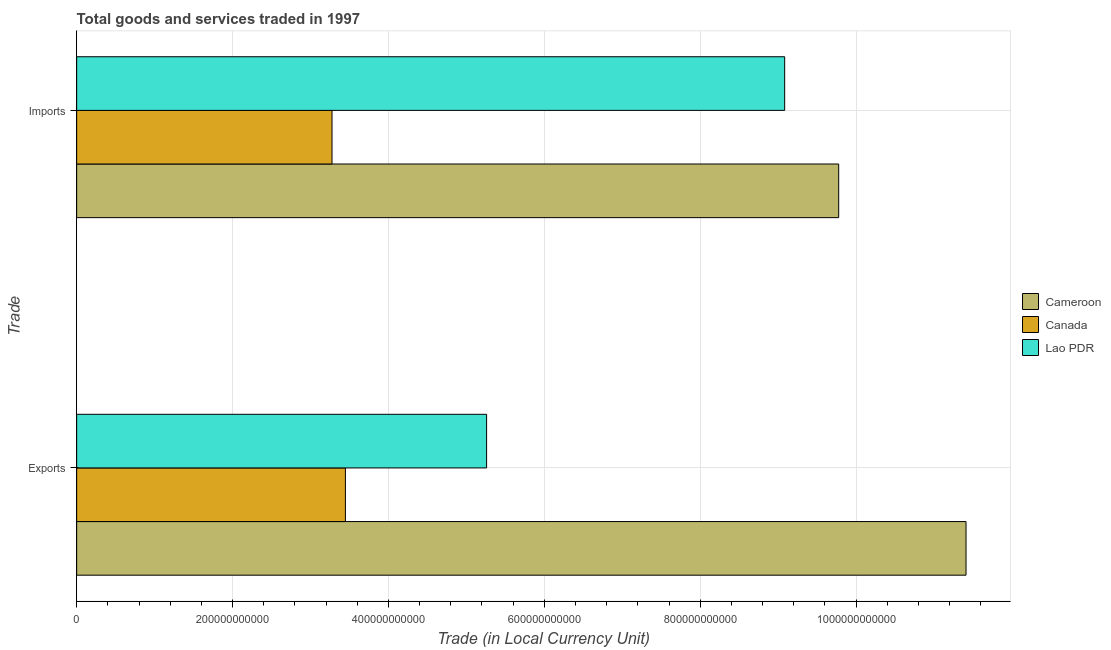How many groups of bars are there?
Make the answer very short. 2. Are the number of bars per tick equal to the number of legend labels?
Your response must be concise. Yes. How many bars are there on the 2nd tick from the top?
Offer a very short reply. 3. How many bars are there on the 2nd tick from the bottom?
Give a very brief answer. 3. What is the label of the 1st group of bars from the top?
Your answer should be very brief. Imports. What is the imports of goods and services in Canada?
Provide a succinct answer. 3.28e+11. Across all countries, what is the maximum imports of goods and services?
Give a very brief answer. 9.78e+11. Across all countries, what is the minimum imports of goods and services?
Your response must be concise. 3.28e+11. In which country was the imports of goods and services maximum?
Keep it short and to the point. Cameroon. In which country was the export of goods and services minimum?
Give a very brief answer. Canada. What is the total imports of goods and services in the graph?
Offer a terse response. 2.21e+12. What is the difference between the export of goods and services in Canada and that in Cameroon?
Ensure brevity in your answer.  -7.96e+11. What is the difference between the imports of goods and services in Canada and the export of goods and services in Cameroon?
Offer a very short reply. -8.13e+11. What is the average export of goods and services per country?
Your answer should be compact. 6.71e+11. What is the difference between the imports of goods and services and export of goods and services in Cameroon?
Offer a terse response. -1.63e+11. What is the ratio of the export of goods and services in Lao PDR to that in Cameroon?
Offer a very short reply. 0.46. In how many countries, is the imports of goods and services greater than the average imports of goods and services taken over all countries?
Keep it short and to the point. 2. What does the 2nd bar from the bottom in Exports represents?
Make the answer very short. Canada. How many bars are there?
Your answer should be very brief. 6. How many countries are there in the graph?
Provide a short and direct response. 3. What is the difference between two consecutive major ticks on the X-axis?
Keep it short and to the point. 2.00e+11. Does the graph contain any zero values?
Your answer should be very brief. No. Does the graph contain grids?
Keep it short and to the point. Yes. How many legend labels are there?
Provide a succinct answer. 3. How are the legend labels stacked?
Ensure brevity in your answer.  Vertical. What is the title of the graph?
Your response must be concise. Total goods and services traded in 1997. What is the label or title of the X-axis?
Ensure brevity in your answer.  Trade (in Local Currency Unit). What is the label or title of the Y-axis?
Provide a short and direct response. Trade. What is the Trade (in Local Currency Unit) in Cameroon in Exports?
Ensure brevity in your answer.  1.14e+12. What is the Trade (in Local Currency Unit) of Canada in Exports?
Provide a short and direct response. 3.45e+11. What is the Trade (in Local Currency Unit) of Lao PDR in Exports?
Make the answer very short. 5.26e+11. What is the Trade (in Local Currency Unit) of Cameroon in Imports?
Provide a short and direct response. 9.78e+11. What is the Trade (in Local Currency Unit) in Canada in Imports?
Your answer should be compact. 3.28e+11. What is the Trade (in Local Currency Unit) of Lao PDR in Imports?
Offer a very short reply. 9.08e+11. Across all Trade, what is the maximum Trade (in Local Currency Unit) of Cameroon?
Provide a short and direct response. 1.14e+12. Across all Trade, what is the maximum Trade (in Local Currency Unit) in Canada?
Provide a succinct answer. 3.45e+11. Across all Trade, what is the maximum Trade (in Local Currency Unit) of Lao PDR?
Make the answer very short. 9.08e+11. Across all Trade, what is the minimum Trade (in Local Currency Unit) in Cameroon?
Offer a terse response. 9.78e+11. Across all Trade, what is the minimum Trade (in Local Currency Unit) of Canada?
Offer a terse response. 3.28e+11. Across all Trade, what is the minimum Trade (in Local Currency Unit) in Lao PDR?
Provide a succinct answer. 5.26e+11. What is the total Trade (in Local Currency Unit) in Cameroon in the graph?
Offer a very short reply. 2.12e+12. What is the total Trade (in Local Currency Unit) in Canada in the graph?
Provide a short and direct response. 6.72e+11. What is the total Trade (in Local Currency Unit) in Lao PDR in the graph?
Your answer should be compact. 1.43e+12. What is the difference between the Trade (in Local Currency Unit) of Cameroon in Exports and that in Imports?
Give a very brief answer. 1.63e+11. What is the difference between the Trade (in Local Currency Unit) in Canada in Exports and that in Imports?
Provide a short and direct response. 1.72e+1. What is the difference between the Trade (in Local Currency Unit) in Lao PDR in Exports and that in Imports?
Ensure brevity in your answer.  -3.82e+11. What is the difference between the Trade (in Local Currency Unit) in Cameroon in Exports and the Trade (in Local Currency Unit) in Canada in Imports?
Give a very brief answer. 8.13e+11. What is the difference between the Trade (in Local Currency Unit) in Cameroon in Exports and the Trade (in Local Currency Unit) in Lao PDR in Imports?
Give a very brief answer. 2.33e+11. What is the difference between the Trade (in Local Currency Unit) of Canada in Exports and the Trade (in Local Currency Unit) of Lao PDR in Imports?
Your answer should be compact. -5.64e+11. What is the average Trade (in Local Currency Unit) of Cameroon per Trade?
Provide a succinct answer. 1.06e+12. What is the average Trade (in Local Currency Unit) in Canada per Trade?
Give a very brief answer. 3.36e+11. What is the average Trade (in Local Currency Unit) of Lao PDR per Trade?
Provide a succinct answer. 7.17e+11. What is the difference between the Trade (in Local Currency Unit) in Cameroon and Trade (in Local Currency Unit) in Canada in Exports?
Offer a very short reply. 7.96e+11. What is the difference between the Trade (in Local Currency Unit) in Cameroon and Trade (in Local Currency Unit) in Lao PDR in Exports?
Provide a succinct answer. 6.15e+11. What is the difference between the Trade (in Local Currency Unit) in Canada and Trade (in Local Currency Unit) in Lao PDR in Exports?
Your answer should be very brief. -1.81e+11. What is the difference between the Trade (in Local Currency Unit) of Cameroon and Trade (in Local Currency Unit) of Canada in Imports?
Give a very brief answer. 6.50e+11. What is the difference between the Trade (in Local Currency Unit) of Cameroon and Trade (in Local Currency Unit) of Lao PDR in Imports?
Offer a very short reply. 6.93e+1. What is the difference between the Trade (in Local Currency Unit) in Canada and Trade (in Local Currency Unit) in Lao PDR in Imports?
Your answer should be very brief. -5.81e+11. What is the ratio of the Trade (in Local Currency Unit) in Cameroon in Exports to that in Imports?
Your answer should be very brief. 1.17. What is the ratio of the Trade (in Local Currency Unit) in Canada in Exports to that in Imports?
Provide a succinct answer. 1.05. What is the ratio of the Trade (in Local Currency Unit) in Lao PDR in Exports to that in Imports?
Keep it short and to the point. 0.58. What is the difference between the highest and the second highest Trade (in Local Currency Unit) of Cameroon?
Your answer should be compact. 1.63e+11. What is the difference between the highest and the second highest Trade (in Local Currency Unit) in Canada?
Ensure brevity in your answer.  1.72e+1. What is the difference between the highest and the second highest Trade (in Local Currency Unit) of Lao PDR?
Offer a terse response. 3.82e+11. What is the difference between the highest and the lowest Trade (in Local Currency Unit) in Cameroon?
Provide a succinct answer. 1.63e+11. What is the difference between the highest and the lowest Trade (in Local Currency Unit) in Canada?
Keep it short and to the point. 1.72e+1. What is the difference between the highest and the lowest Trade (in Local Currency Unit) of Lao PDR?
Provide a succinct answer. 3.82e+11. 